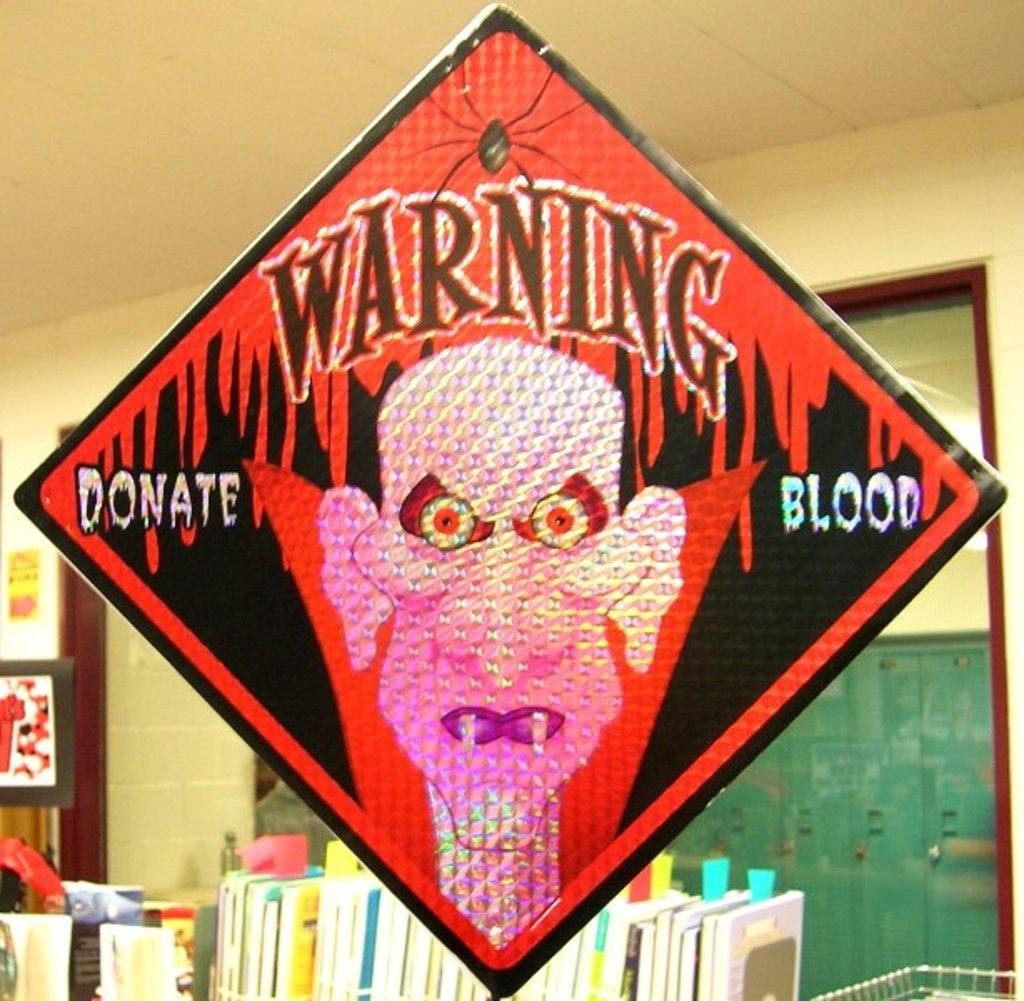<image>
Give a short and clear explanation of the subsequent image. A diamond shaped "Warning" sign with a cartoon vampire on it. 